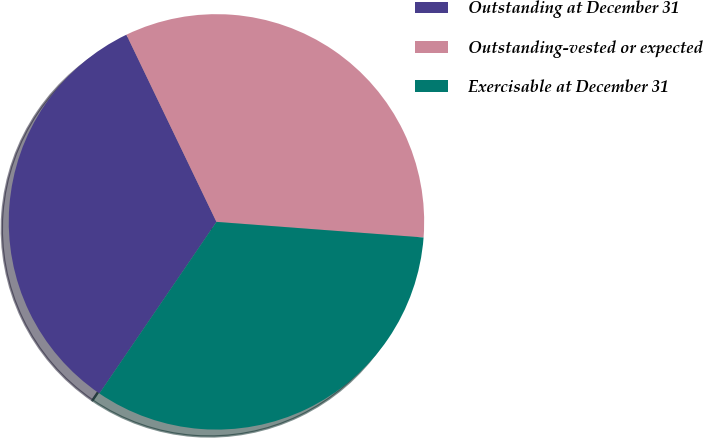Convert chart. <chart><loc_0><loc_0><loc_500><loc_500><pie_chart><fcel>Outstanding at December 31<fcel>Outstanding-vested or expected<fcel>Exercisable at December 31<nl><fcel>33.33%<fcel>33.33%<fcel>33.33%<nl></chart> 